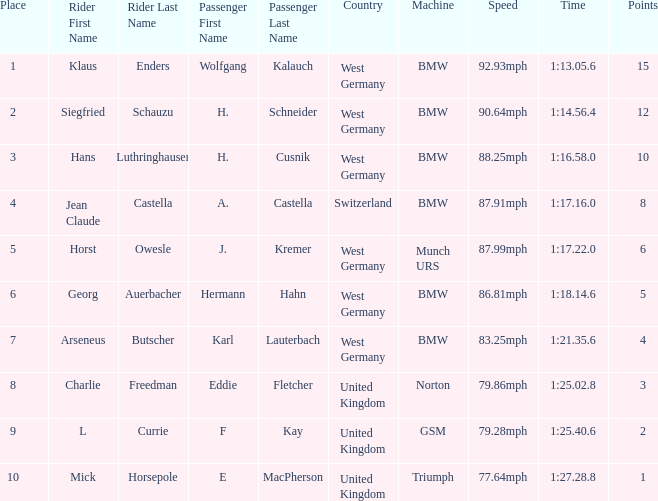Which places have points larger than 10? None. Can you give me this table as a dict? {'header': ['Place', 'Rider First Name', 'Rider Last Name', 'Passenger First Name', 'Passenger Last Name', 'Country', 'Machine', 'Speed', 'Time', 'Points'], 'rows': [['1', 'Klaus', 'Enders', 'Wolfgang', 'Kalauch', 'West Germany', 'BMW', '92.93mph', '1:13.05.6', '15'], ['2', 'Siegfried', 'Schauzu', 'H.', 'Schneider', 'West Germany', 'BMW', '90.64mph', '1:14.56.4', '12'], ['3', 'Hans', 'Luthringhauser', 'H.', 'Cusnik', 'West Germany', 'BMW', '88.25mph', '1:16.58.0', '10'], ['4', 'Jean Claude', 'Castella', 'A.', 'Castella', 'Switzerland', 'BMW', '87.91mph', '1:17.16.0', '8'], ['5', 'Horst', 'Owesle', 'J.', 'Kremer', 'West Germany', 'Munch URS', '87.99mph', '1:17.22.0', '6'], ['6', 'Georg', 'Auerbacher', 'Hermann', 'Hahn', 'West Germany', 'BMW', '86.81mph', '1:18.14.6', '5'], ['7', 'Arseneus', 'Butscher', 'Karl', 'Lauterbach', 'West Germany', 'BMW', '83.25mph', '1:21.35.6', '4'], ['8', 'Charlie', 'Freedman', 'Eddie', 'Fletcher', 'United Kingdom', 'Norton', '79.86mph', '1:25.02.8', '3'], ['9', 'L', 'Currie', 'F', 'Kay', 'United Kingdom', 'GSM', '79.28mph', '1:25.40.6', '2'], ['10', 'Mick', 'Horsepole', 'E', 'MacPherson', 'United Kingdom', 'Triumph', '77.64mph', '1:27.28.8', '1']]} 